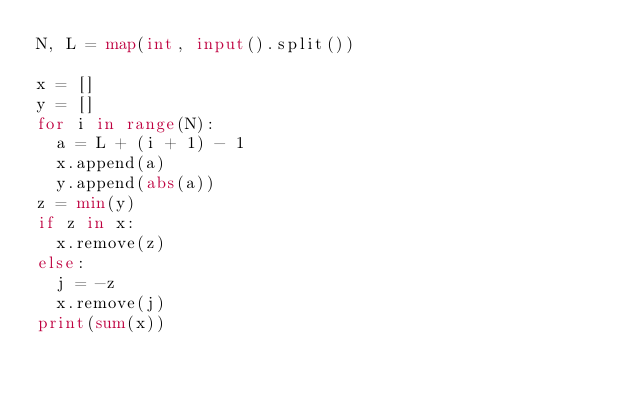Convert code to text. <code><loc_0><loc_0><loc_500><loc_500><_Python_>N, L = map(int, input().split())

x = []
y = []
for i in range(N):
  a = L + (i + 1) - 1
  x.append(a)
  y.append(abs(a))
z = min(y)
if z in x:
  x.remove(z)
else:
  j = -z
  x.remove(j)
print(sum(x))</code> 